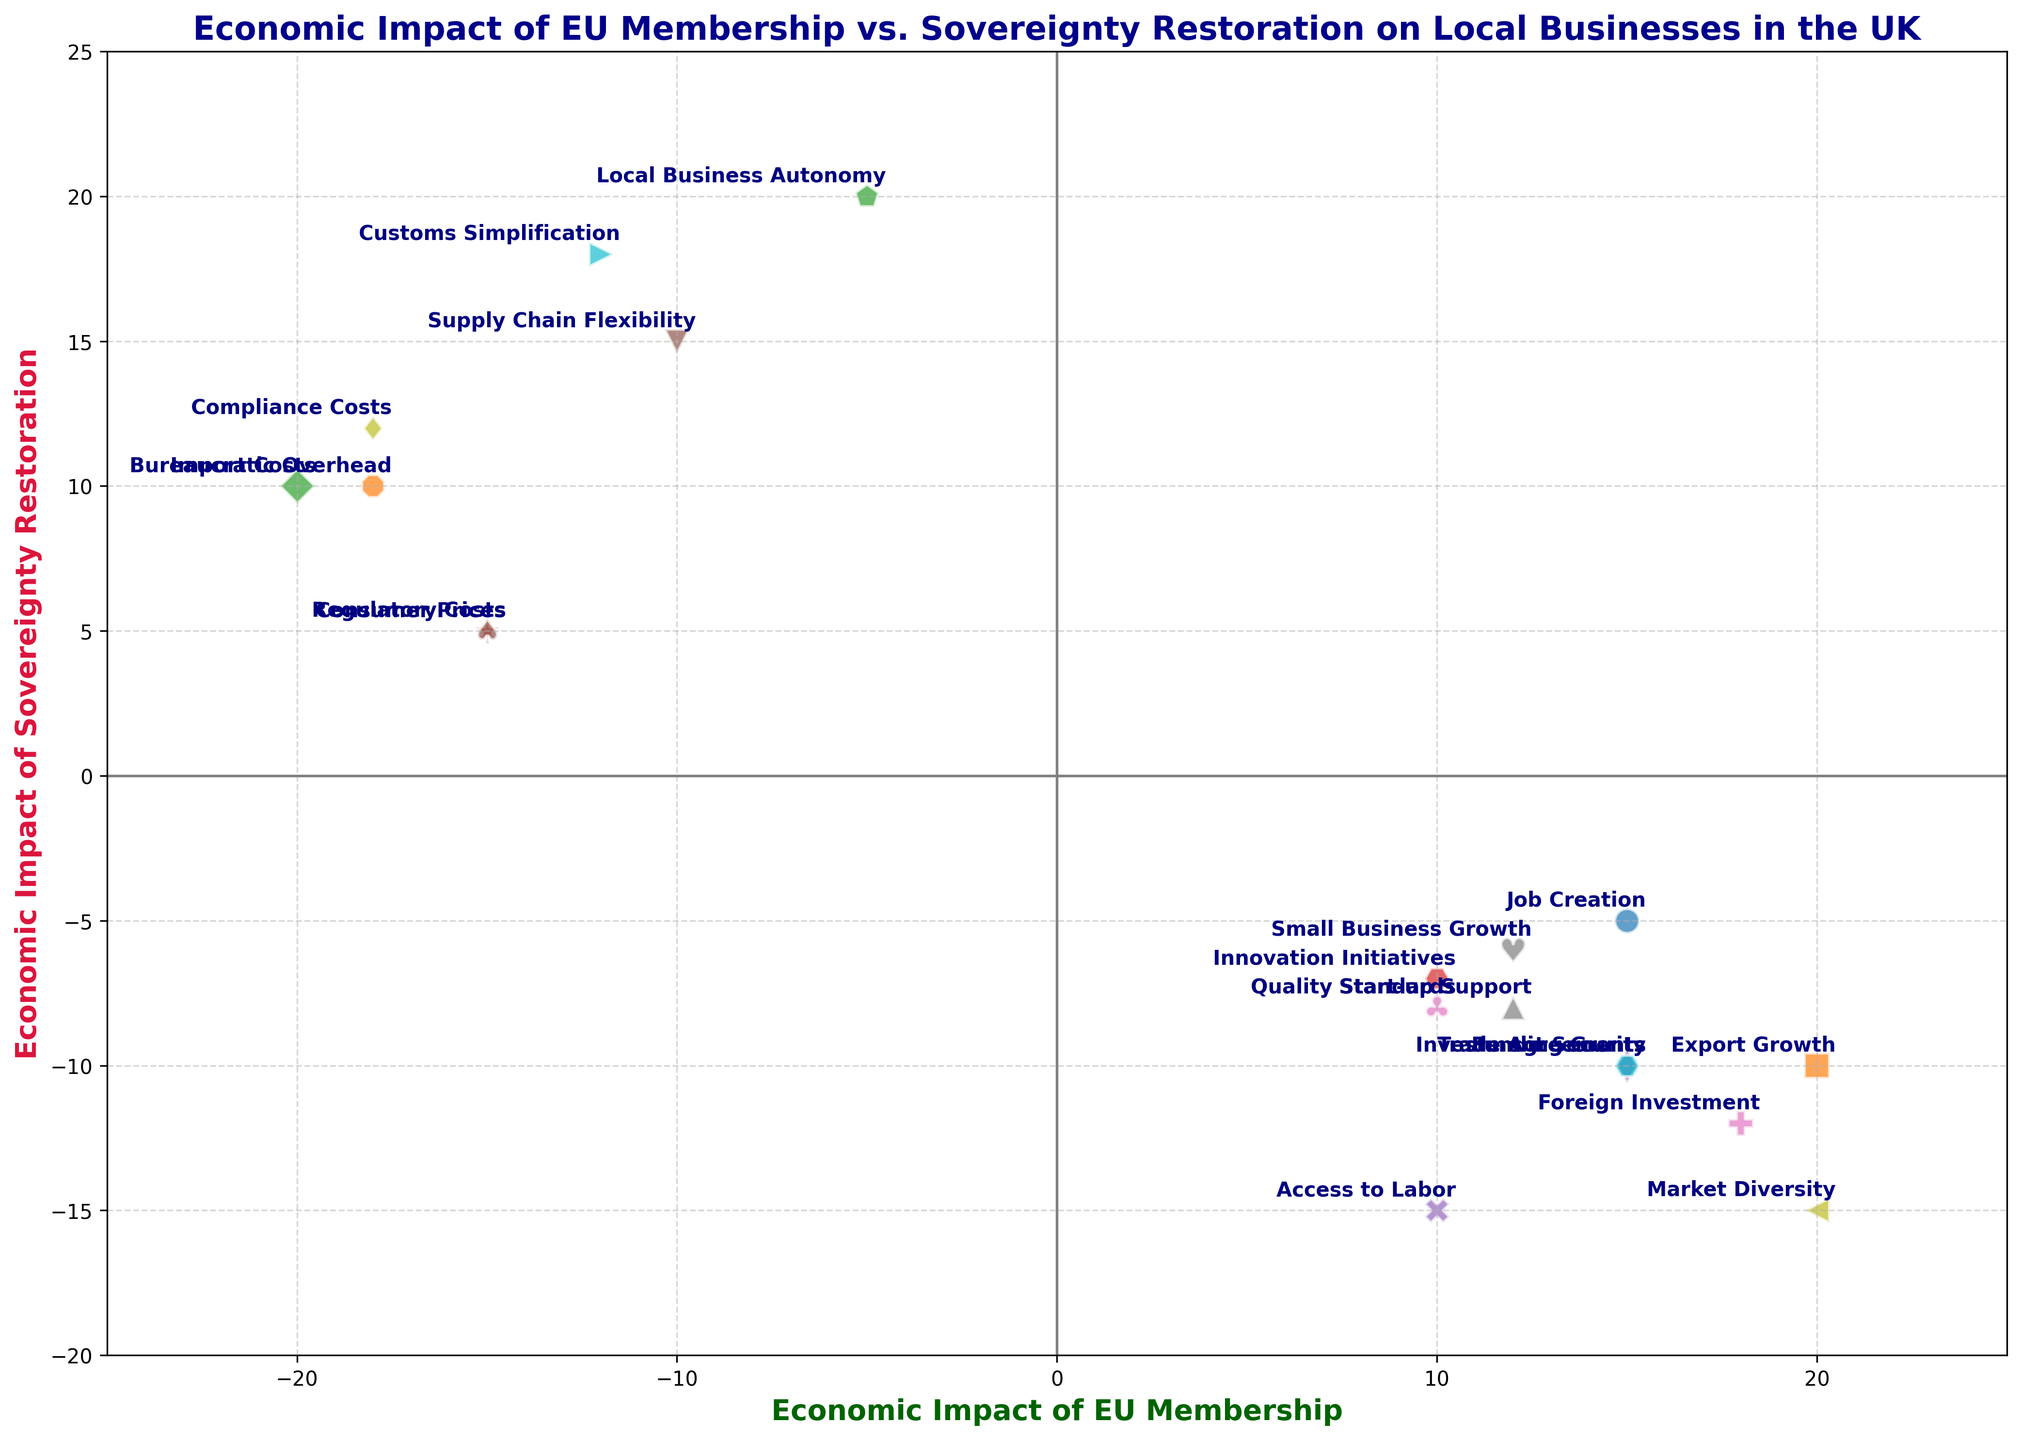What is the difference in economic impact on Job Creation between EU Membership and Sovereignty Restoration? To find the difference in economic impact, subtract the Sovereignty Restoration impact from the EU Membership impact for Job Creation. This gives 15 - (-5) = 15 + 5 = 20.
Answer: 20 Which impact has the highest positive value under Sovereignty Restoration? Look through the data points for Sovereignty Restoration and find the highest positive value. Local Business Autonomy has the highest positive value at 20.
Answer: Local Business Autonomy How does the impact on Import Costs compare between EU Membership and Sovereignty Restoration? The impact on Import Costs under EU Membership is -20, while under Sovereignty Restoration it is 10. EU Membership negatively impacts Import Costs, whereas Sovereignty Restoration positively impacts it.
Answer: EU Membership: -20, Sovereignty Restoration: 10 What is the overall trend for consumer prices between EU Membership and Sovereignty Restoration? For Consumer Prices, the economic impact under EU Membership is -15, and under Sovereignty Restoration, it is 5. This indicates that EU Membership decreases consumer prices, whereas Sovereignty Restoration increases them.
Answer: EU Membership decreases, Sovereignty Restoration increases Which factor shows the greatest negative impact under EU Membership? By observing the data points for EU Membership, Bureaucratic Overhead has the greatest negative impact with a value of -18.
Answer: Bureaucratic Overhead What is the combined impact on Regulatory Costs for both EU Membership and Sovereignty Restoration? Combine the impacts of Regulatory Costs under both conditions by adding the values together. This gives -15 + 5 = -10.
Answer: -10 Is there any factor where both EU Membership and Sovereignty Restoration have a negative impact? Look for a data point where both EU Membership and Sovereignty Restoration have negative values. Access to Labor shows negative impacts in both, with 10 for EU Membership and -15 for Sovereignty Restoration.
Answer: Access to Labor What visual pattern can be observed for the plot markers used for plotted impacts? The markers used in the plot vary in shape for each impact to help distinguish them visually. Each impact has a unique marker.
Answer: Unique markers for each impact Which impact shows the greatest positive value in EU Membership? By reviewing the data points under EU Membership, Export Growth shows the greatest positive impact with a value of 20.
Answer: Export Growth 